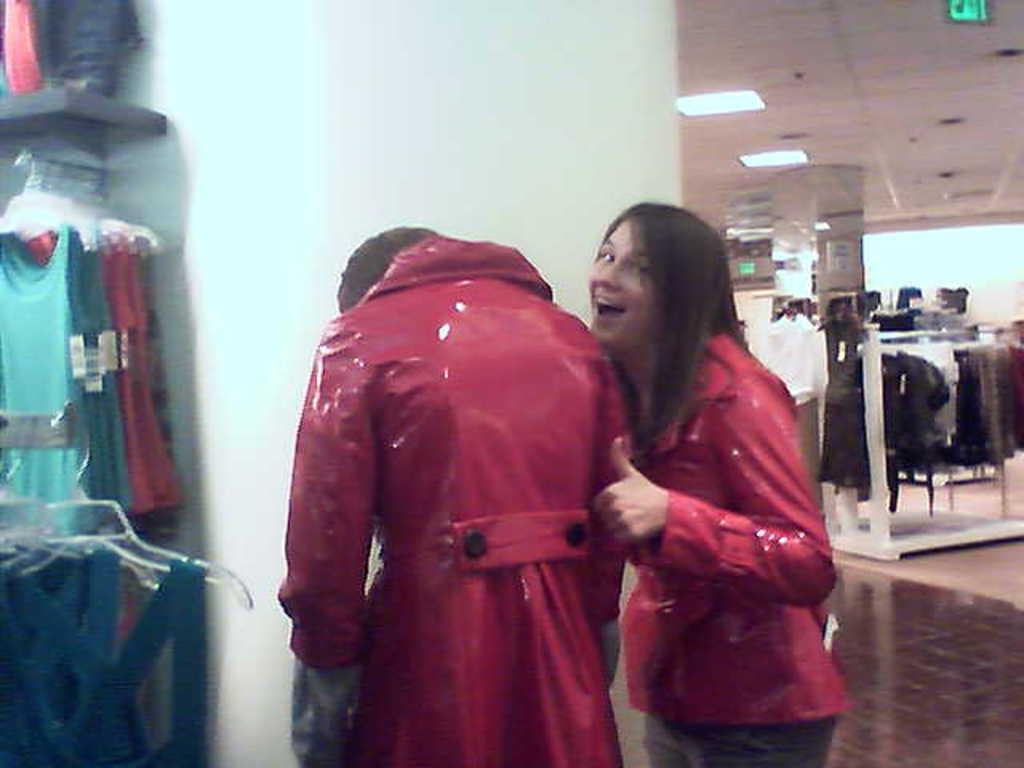Who can be seen in the image? There is a woman and a man in the image. Where are they located? They are standing in a shopping mall. What type of clothing can be found in the shopping mall? There are dresses in the shopping mall. What part of the shopping mall's interior is visible in the image? The ceiling is visible in the image. What type of illumination is present in the image? There are lights in the image. How many frogs are sitting on the woman's throat in the image? There are no frogs present in the image, let alone on the woman's throat. What type of bee can be seen buzzing around the man's head in the image? There is no bee present in the image, so it cannot be determined what type of bee might be buzzing around the man's head. 